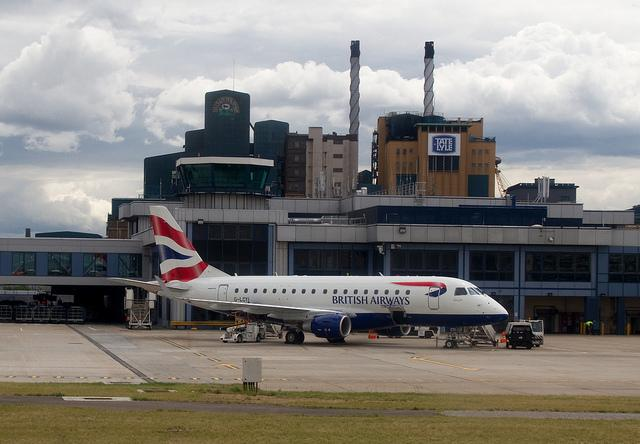What is placed in the underneath of a plane storage? luggage 